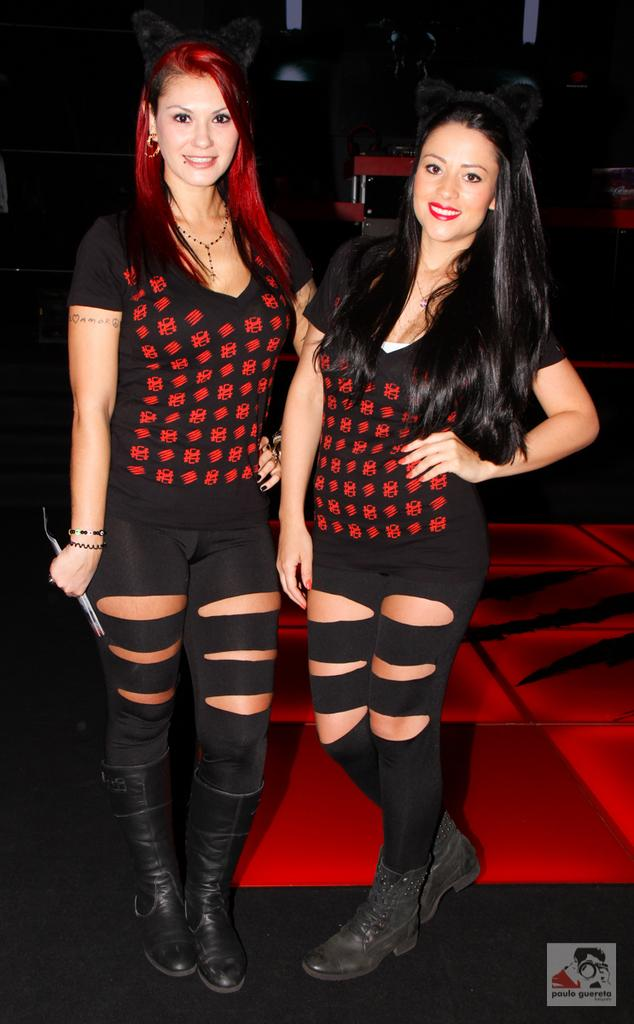How many women are in the image? There are two women in the center of the picture. What are the women wearing? The women are wearing black dresses. What color is the floor in the image? The floor is red. What can be seen in the background of the image? There are chairs in the background of the image. Where is the camera located in the image? There is no camera visible in the image. Can you see a nest in the image? There is no nest present in the image. 